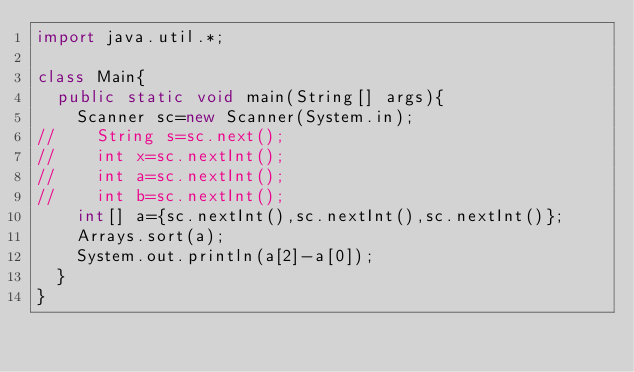<code> <loc_0><loc_0><loc_500><loc_500><_Java_>import java.util.*;

class Main{
  public static void main(String[] args){
    Scanner sc=new Scanner(System.in);
//    String s=sc.next();
//    int x=sc.nextInt();
//    int a=sc.nextInt();
//    int b=sc.nextInt();
    int[] a={sc.nextInt(),sc.nextInt(),sc.nextInt()};
    Arrays.sort(a);
    System.out.println(a[2]-a[0]);
  }
}</code> 